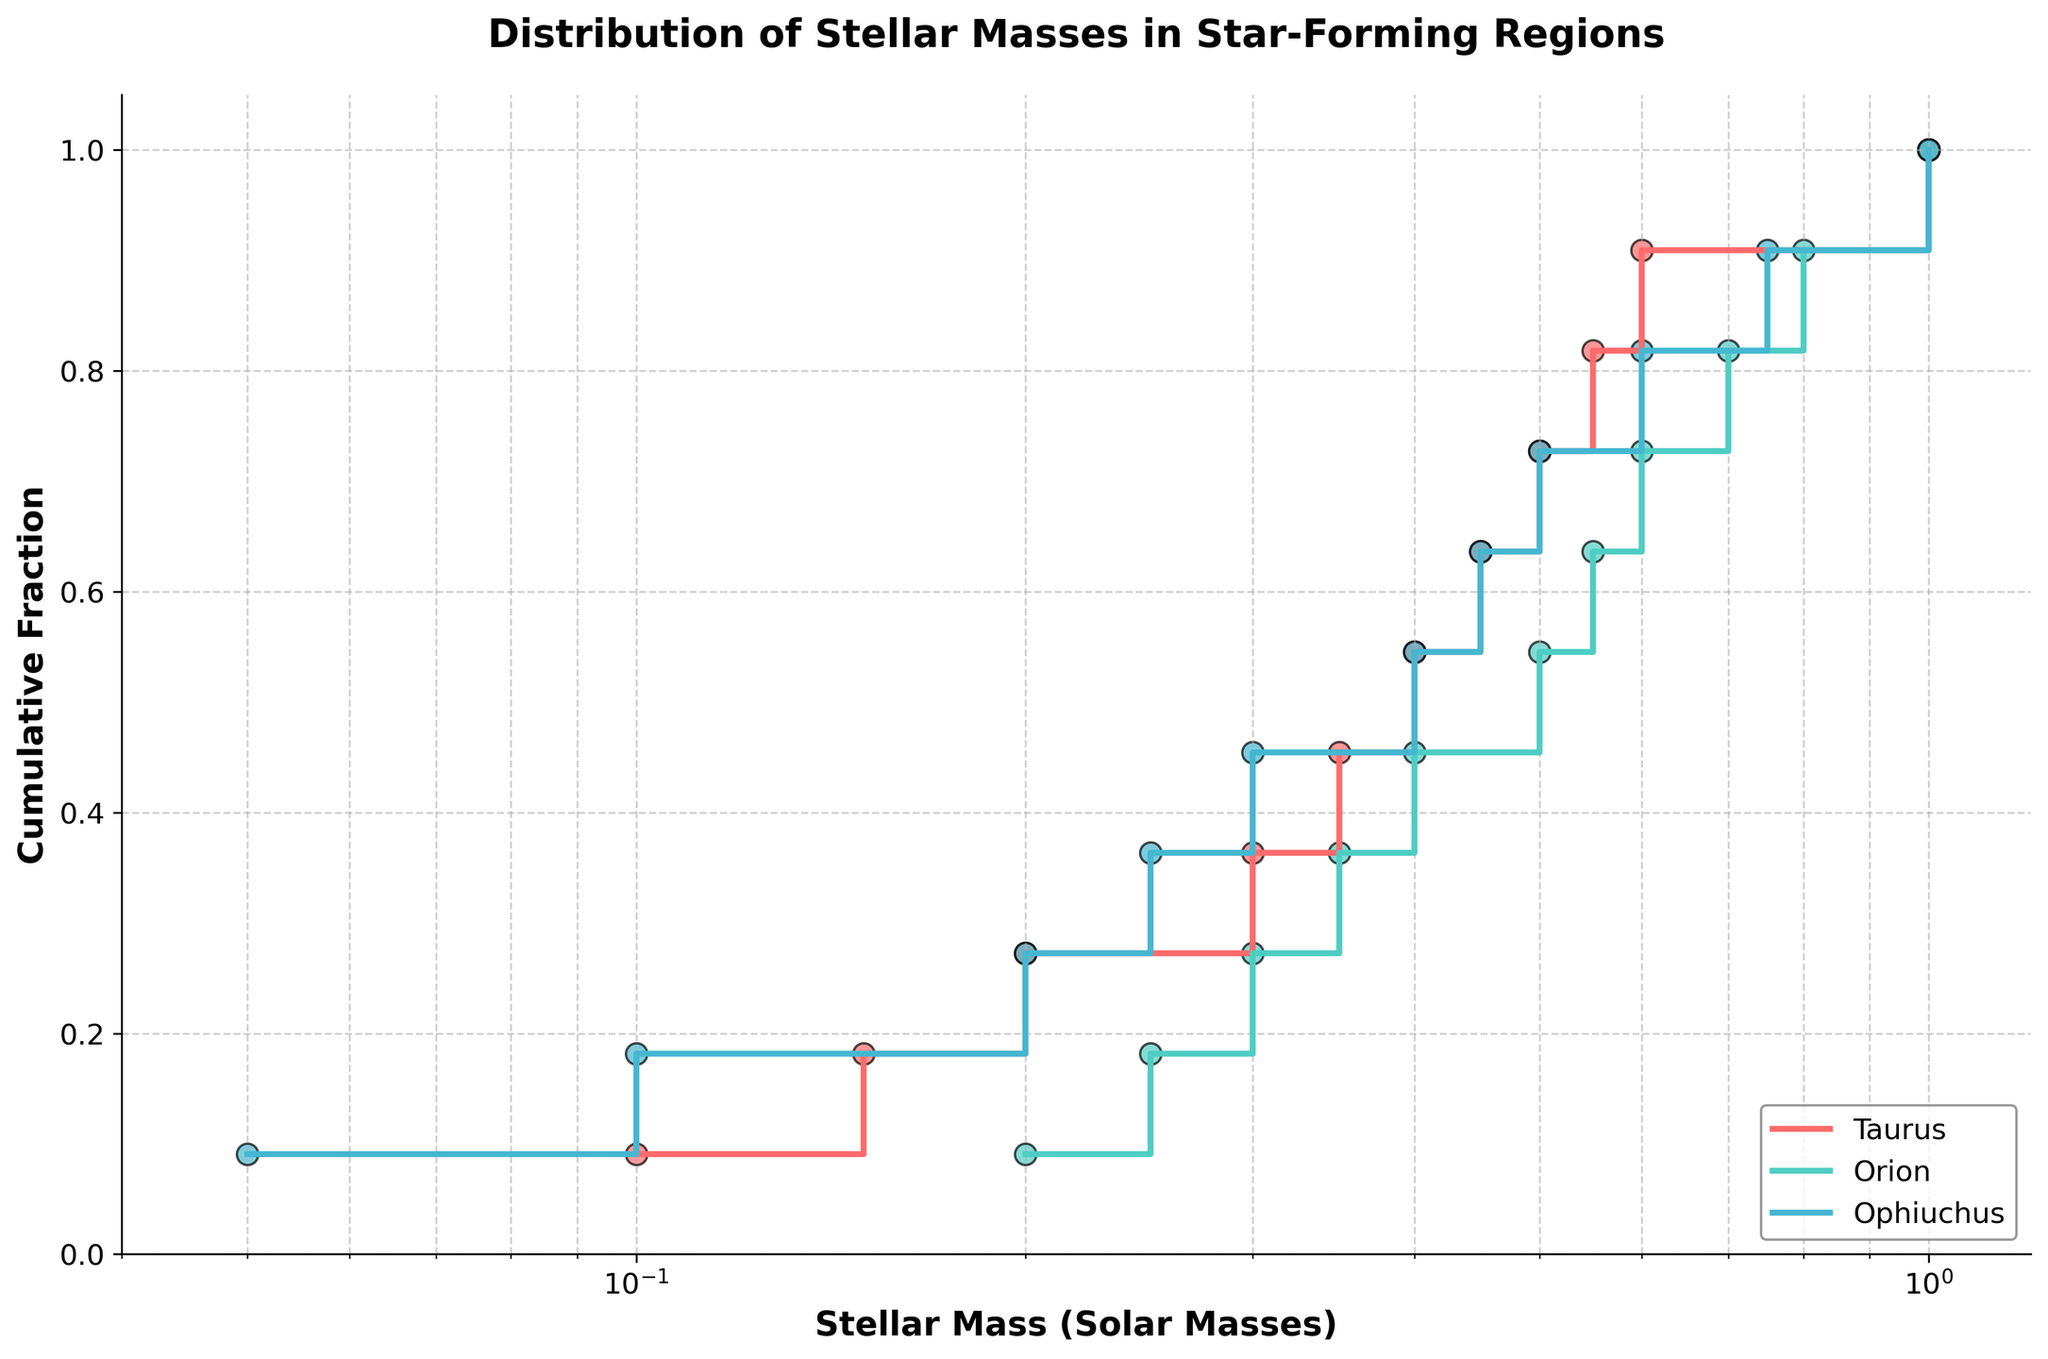What is the title of the plot? The title of the plot is displayed at the top of the figure and provides an overview of what the figure represents. Here, it reads "Distribution of Stellar Masses in Star-Forming Regions".
Answer: Distribution of Stellar Masses in Star-Forming Regions What is the range of the x-axis? The x-axis represents Stellar Mass (Solar Masses), and the labels indicate that it ranges from 0.04 to 1.2 with a logarithmic scale.
Answer: 0.04 to 1.2 Which star-forming region has the most data points? By comparing the number of steps for each line in the plot, it can be determined that Orion, with 11 data points, has the most.
Answer: Orion In which star-forming region do we see stars with the lowest masses? By observing the plot, the Ophiuchus region's line starts at the lowest mass value, around 0.05 solar masses.
Answer: Ophiuchus How does the cumulative fraction of stellar masses differ between the Taurus and Orion regions at 0.5 solar masses? By observing the cumulative fraction at 0.5 solar masses, we see that Orion's cumulative fraction is higher than Taurus's.
Answer: Orion has a higher cumulative fraction at 0.5 solar masses Compare the distribution of stars between Ophiuchus and Taurus at 0.3 solar masses. By examining the step heights at 0.3 solar masses, the cumulative fraction in Ophiuchus is higher as compared to Taurus.
Answer: Ophiuchus has a higher cumulative fraction at 0.3 solar masses What proportion of stars in the Orion region have masses less than 0.4 solar masses? From the plot, trace the step of Orion up to 0.4 solar masses. The cumulative fraction is approximately 0.45.
Answer: About 45% Which region has the steepest initial slope? The steepest initial slope indicates the region with the highest fraction of low-mass stars. Ophiuchus has the steepest initial slope, showing a rapid climb initially.
Answer: Ophiuchus At what stellar mass do Taurus and Orion first reach or surpass a cumulative fraction of 0.5? By observing the steps, Taurus reaches or surpasses a cumulative fraction of 0.5 at approximately 0.5 solar masses, while Orion does so at around 0.4 solar masses.
Answer: Taurus: ~0.5 solar masses, Orion: ~0.4 solar masses 